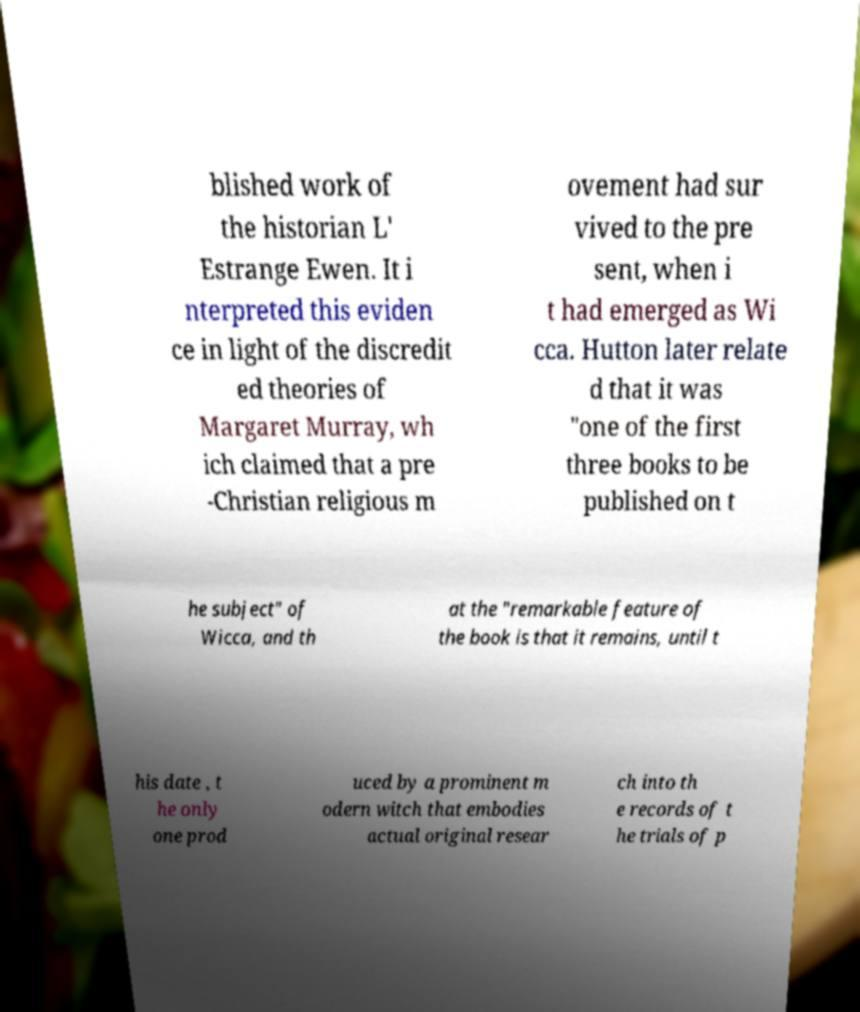Can you read and provide the text displayed in the image?This photo seems to have some interesting text. Can you extract and type it out for me? blished work of the historian L' Estrange Ewen. It i nterpreted this eviden ce in light of the discredit ed theories of Margaret Murray, wh ich claimed that a pre -Christian religious m ovement had sur vived to the pre sent, when i t had emerged as Wi cca. Hutton later relate d that it was "one of the first three books to be published on t he subject" of Wicca, and th at the "remarkable feature of the book is that it remains, until t his date , t he only one prod uced by a prominent m odern witch that embodies actual original resear ch into th e records of t he trials of p 